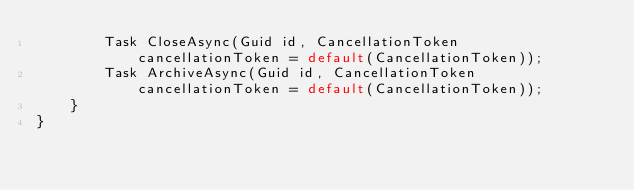<code> <loc_0><loc_0><loc_500><loc_500><_C#_>        Task CloseAsync(Guid id, CancellationToken cancellationToken = default(CancellationToken));
        Task ArchiveAsync(Guid id, CancellationToken cancellationToken = default(CancellationToken));
    }
}
</code> 